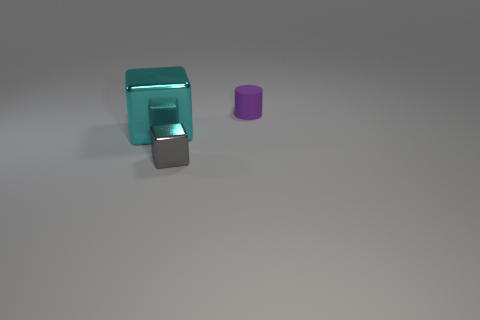Is there anything else that is the same material as the purple cylinder?
Offer a very short reply. No. Is there any other thing that has the same size as the cyan metallic object?
Ensure brevity in your answer.  No. How many metallic things are cyan spheres or cylinders?
Your answer should be very brief. 0. Is there another matte thing that has the same color as the big thing?
Your answer should be very brief. No. Are there any small shiny objects?
Make the answer very short. Yes. Do the large thing and the small gray object have the same shape?
Provide a short and direct response. Yes. How many big things are red metal objects or gray metal cubes?
Keep it short and to the point. 0. The matte cylinder has what color?
Provide a succinct answer. Purple. There is a metal object that is behind the metallic block to the right of the big cyan block; what shape is it?
Make the answer very short. Cube. Is there a tiny purple cylinder that has the same material as the purple object?
Offer a very short reply. No. 